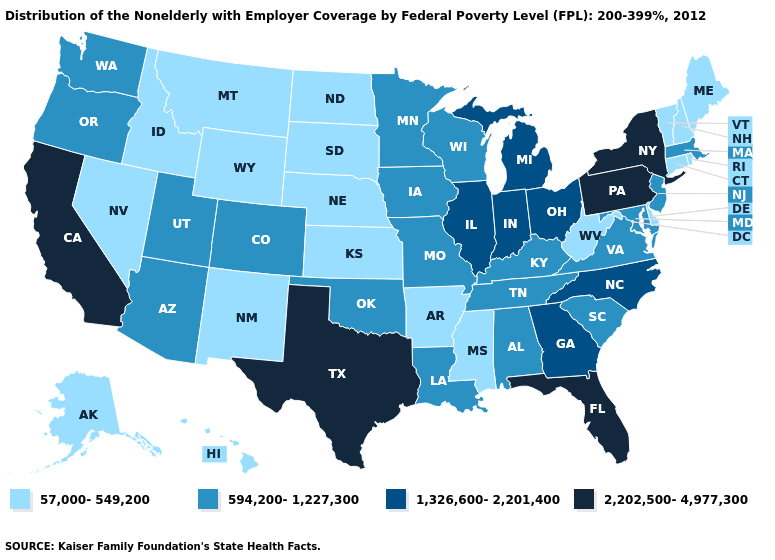What is the value of Kentucky?
Keep it brief. 594,200-1,227,300. What is the lowest value in the USA?
Quick response, please. 57,000-549,200. Does New York have the highest value in the Northeast?
Give a very brief answer. Yes. Does Colorado have a lower value than Iowa?
Quick response, please. No. Does New Mexico have the highest value in the West?
Be succinct. No. What is the value of Mississippi?
Give a very brief answer. 57,000-549,200. What is the value of Nevada?
Short answer required. 57,000-549,200. Name the states that have a value in the range 594,200-1,227,300?
Short answer required. Alabama, Arizona, Colorado, Iowa, Kentucky, Louisiana, Maryland, Massachusetts, Minnesota, Missouri, New Jersey, Oklahoma, Oregon, South Carolina, Tennessee, Utah, Virginia, Washington, Wisconsin. Does the first symbol in the legend represent the smallest category?
Be succinct. Yes. What is the value of Michigan?
Give a very brief answer. 1,326,600-2,201,400. Among the states that border South Carolina , which have the highest value?
Keep it brief. Georgia, North Carolina. What is the value of Maryland?
Concise answer only. 594,200-1,227,300. What is the lowest value in the USA?
Short answer required. 57,000-549,200. What is the highest value in states that border Florida?
Answer briefly. 1,326,600-2,201,400. What is the highest value in the USA?
Concise answer only. 2,202,500-4,977,300. 